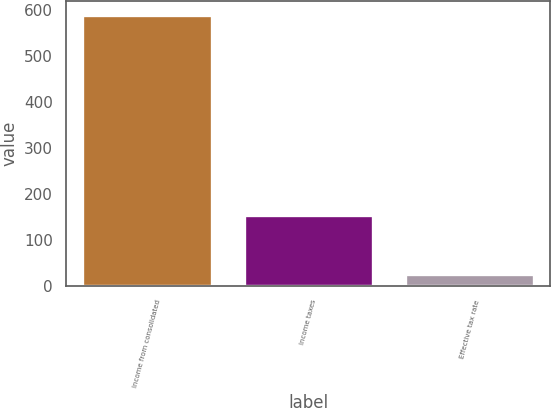<chart> <loc_0><loc_0><loc_500><loc_500><bar_chart><fcel>Income from consolidated<fcel>Income taxes<fcel>Effective tax rate<nl><fcel>589.2<fcel>153<fcel>26<nl></chart> 